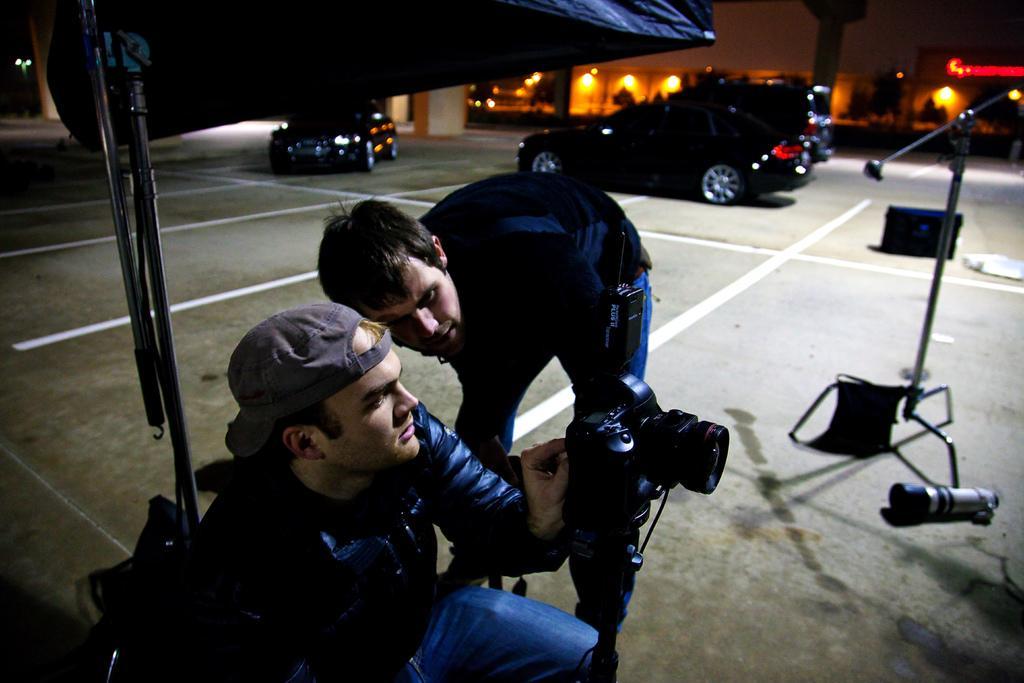Can you describe this image briefly? In this image, I can see a person sitting and another person standing. In front of two persons, there is a camera with a stand. I can see the stands and few other objects. In the background, there are vehicles on the road, buildings, lights and trees. 